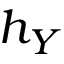<formula> <loc_0><loc_0><loc_500><loc_500>h _ { Y }</formula> 